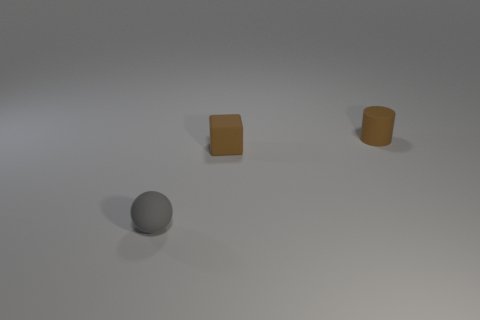Are there fewer tiny spheres that are in front of the small rubber sphere than cubes right of the brown block?
Your answer should be compact. No. Are there any other small objects that have the same shape as the tiny gray object?
Offer a terse response. No. What number of tiny objects are either gray balls or matte things?
Offer a very short reply. 3. Is the number of large yellow matte things greater than the number of tiny gray matte objects?
Offer a terse response. No. What is the size of the cylinder that is the same material as the ball?
Make the answer very short. Small. There is a object behind the brown block; is its size the same as the brown object that is to the left of the tiny cylinder?
Provide a succinct answer. Yes. What number of things are either small things behind the small cube or balls?
Offer a very short reply. 2. Is the number of tiny gray spheres less than the number of large cyan balls?
Keep it short and to the point. No. The brown thing behind the brown rubber object in front of the small brown rubber object that is to the right of the small brown block is what shape?
Offer a terse response. Cylinder. There is a object that is the same color as the cylinder; what is its shape?
Provide a short and direct response. Cube. 